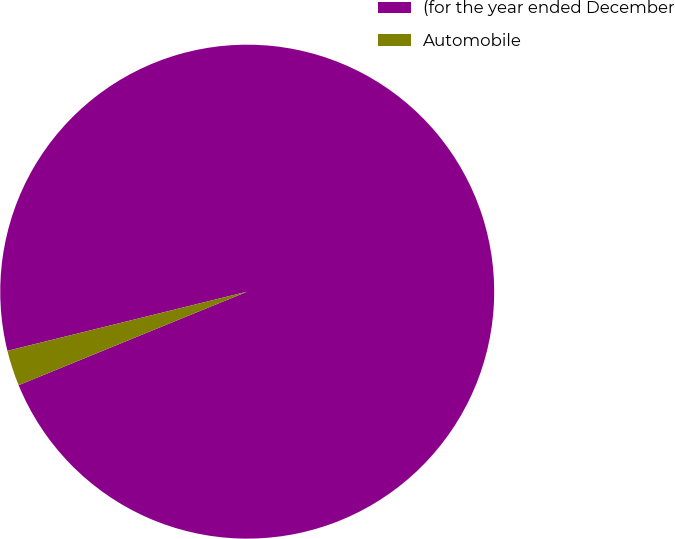<chart> <loc_0><loc_0><loc_500><loc_500><pie_chart><fcel>(for the year ended December<fcel>Automobile<nl><fcel>97.67%<fcel>2.33%<nl></chart> 